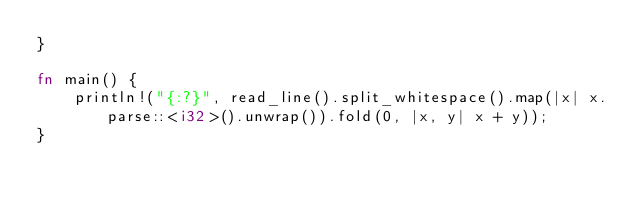Convert code to text. <code><loc_0><loc_0><loc_500><loc_500><_Rust_>}

fn main() {
    println!("{:?}", read_line().split_whitespace().map(|x| x.parse::<i32>().unwrap()).fold(0, |x, y| x + y));
}</code> 